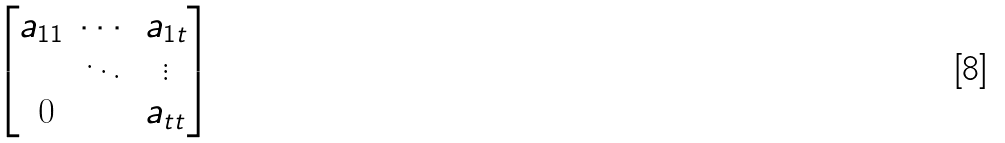<formula> <loc_0><loc_0><loc_500><loc_500>\begin{bmatrix} a _ { 1 1 } & \cdots & a _ { 1 t } \\ & \ddots & \vdots \\ \text { 0} & & a _ { t t } \end{bmatrix}</formula> 